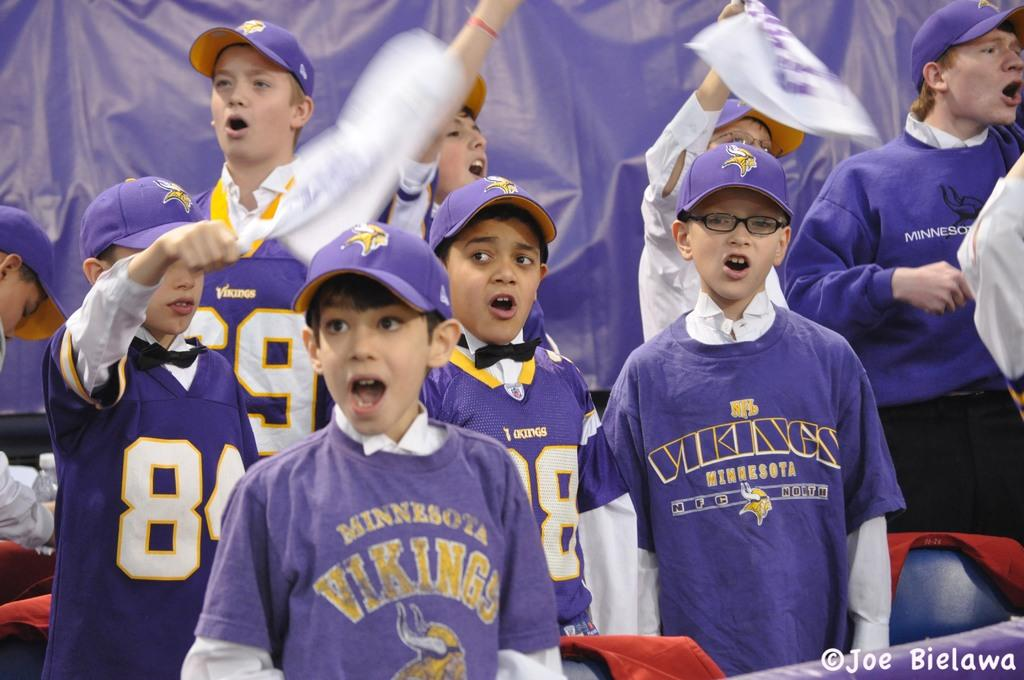<image>
Create a compact narrative representing the image presented. Bunch of Kids at a Minnnesota Vikings game cheering on their team. 